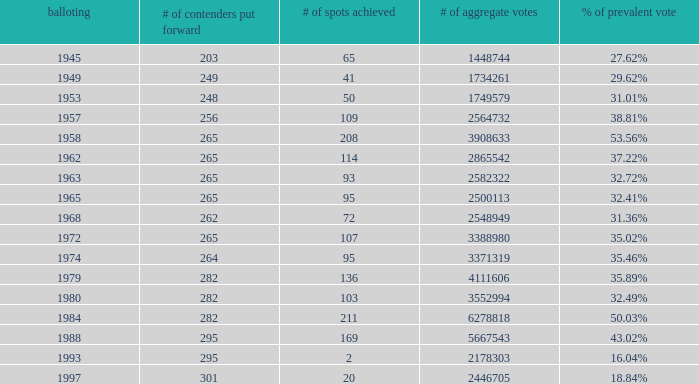What was the minimum quantity of total votes? 1448744.0. 